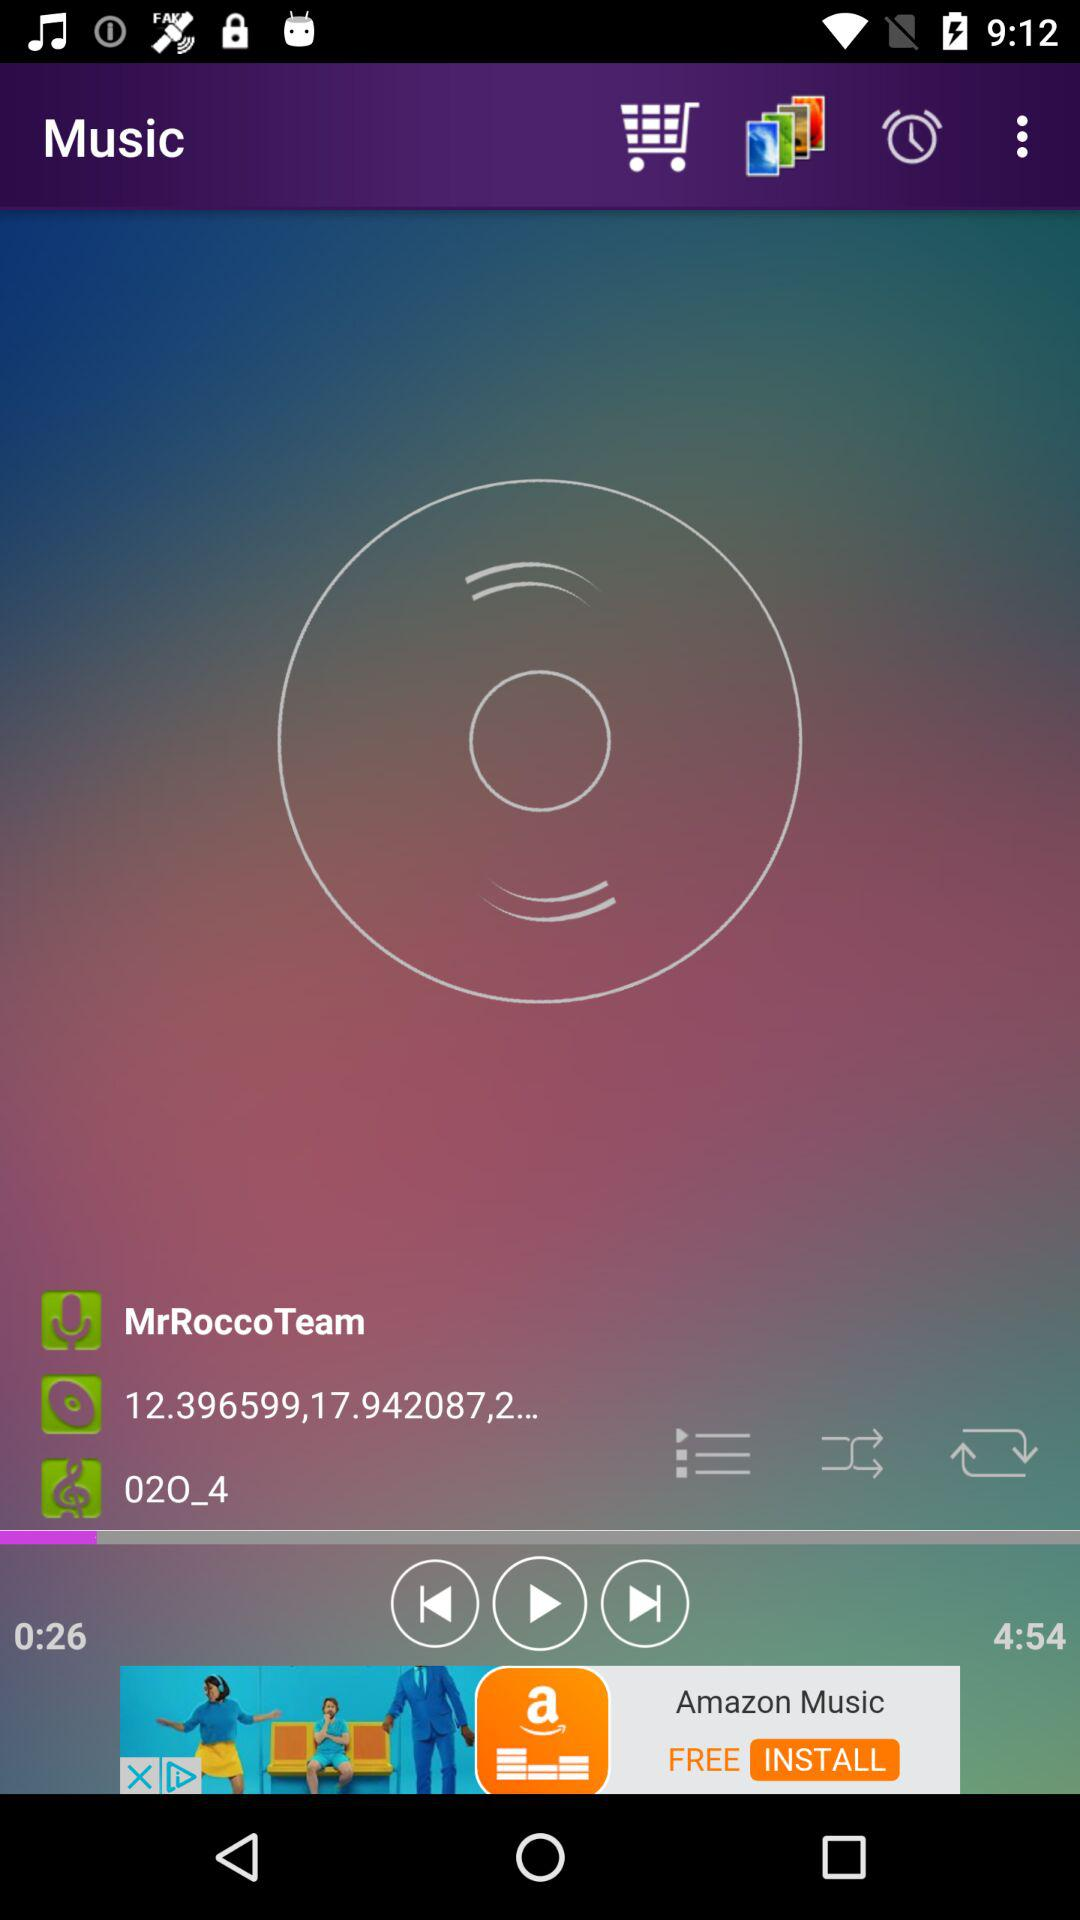How many new messages are there?
When the provided information is insufficient, respond with <no answer>. <no answer> 